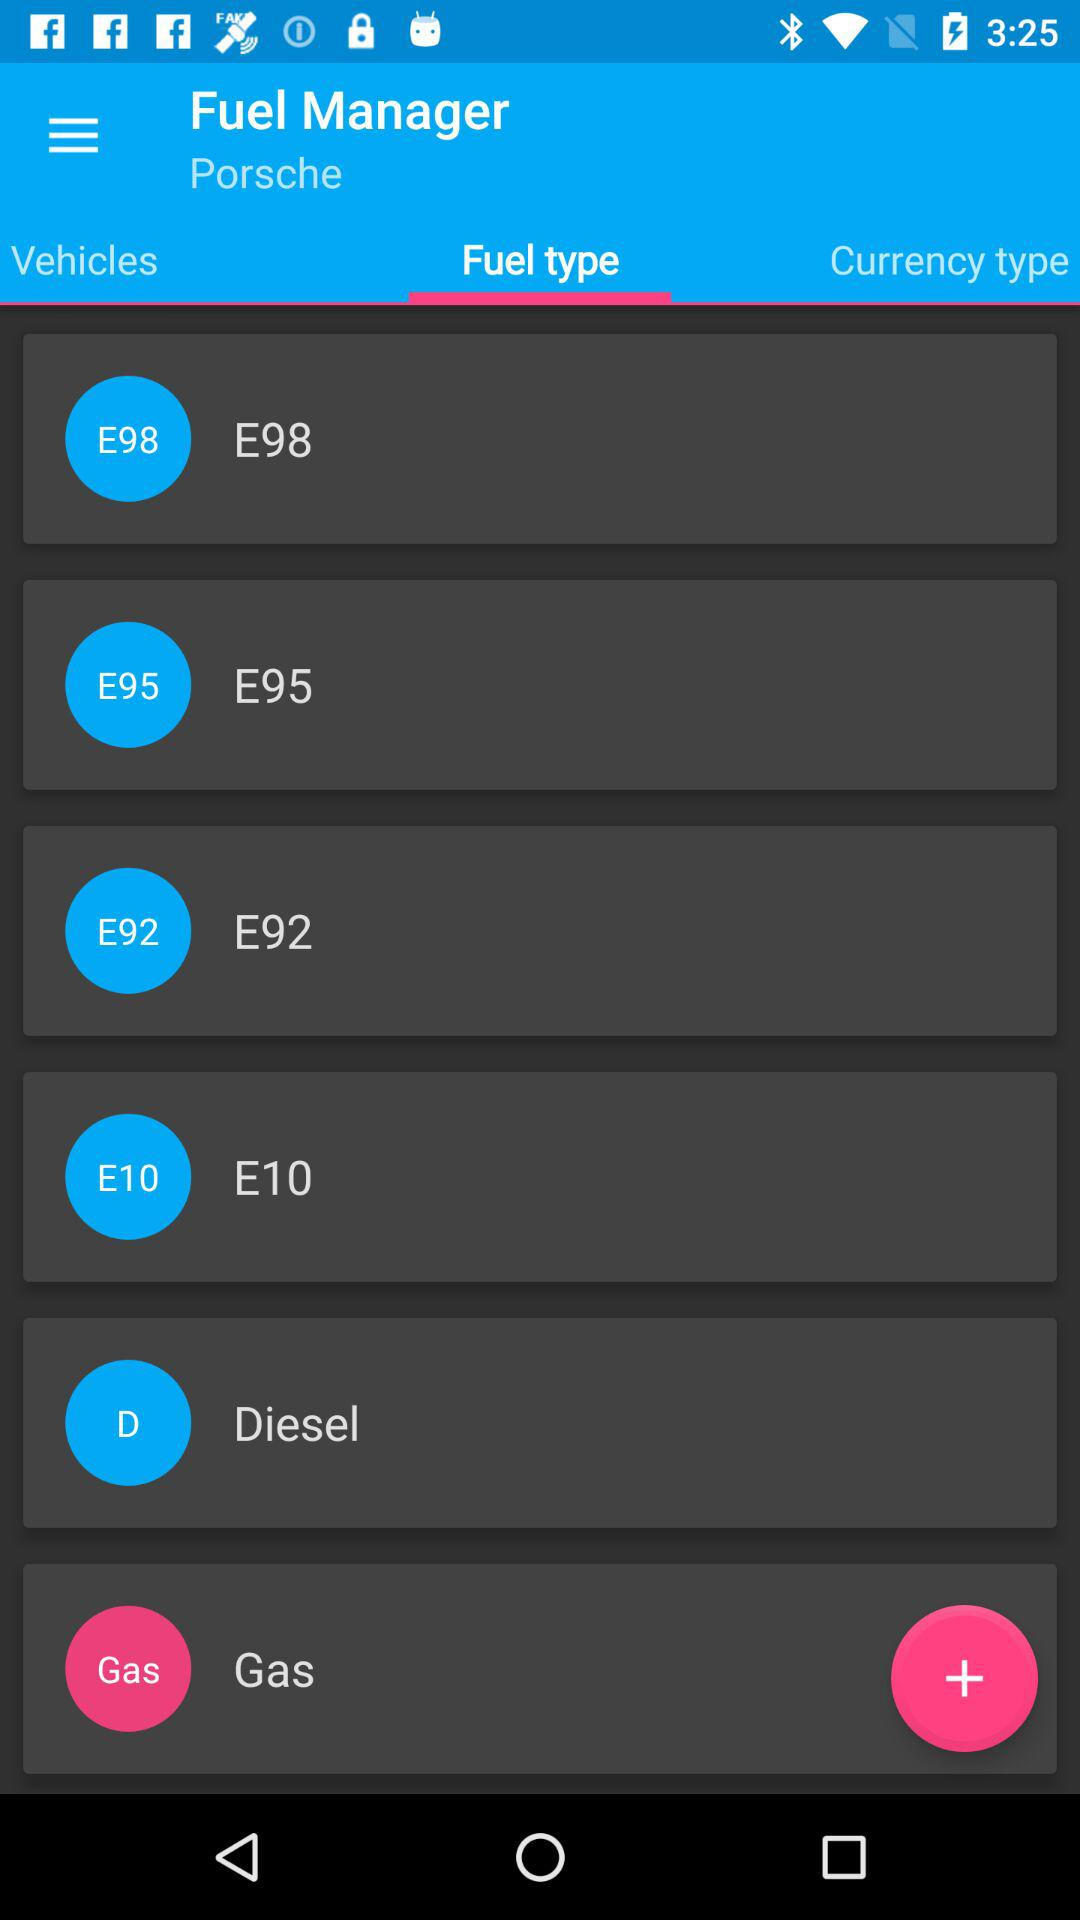Which tab is open? The tab that is open is "Fuel type". 